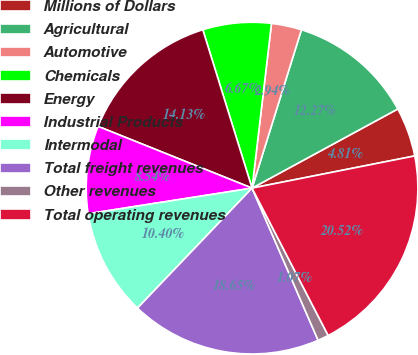Convert chart. <chart><loc_0><loc_0><loc_500><loc_500><pie_chart><fcel>Millions of Dollars<fcel>Agricultural<fcel>Automotive<fcel>Chemicals<fcel>Energy<fcel>Industrial Products<fcel>Intermodal<fcel>Total freight revenues<fcel>Other revenues<fcel>Total operating revenues<nl><fcel>4.81%<fcel>12.27%<fcel>2.94%<fcel>6.67%<fcel>14.13%<fcel>8.54%<fcel>10.4%<fcel>18.65%<fcel>1.07%<fcel>20.52%<nl></chart> 